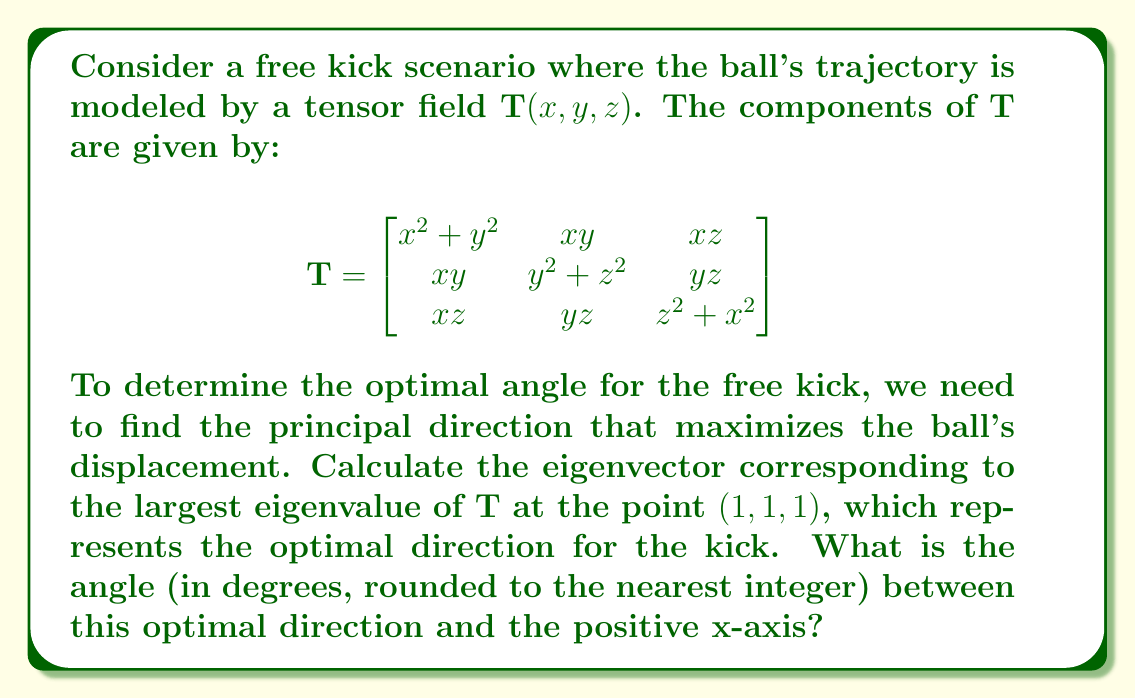Show me your answer to this math problem. To solve this problem, we'll follow these steps:

1) First, we need to evaluate the tensor $\mathbf{T}$ at the point $(1,1,1)$:

   $$\mathbf{T}(1,1,1) = \begin{bmatrix}
   2 & 1 & 1 \\
   1 & 2 & 1 \\
   1 & 1 & 2
   \end{bmatrix}$$

2) Now, we need to find the eigenvalues of this matrix. The characteristic equation is:

   $$\det(\mathbf{T} - \lambda \mathbf{I}) = 0$$
   
   $$\begin{vmatrix}
   2-\lambda & 1 & 1 \\
   1 & 2-\lambda & 1 \\
   1 & 1 & 2-\lambda
   \end{vmatrix} = 0$$

3) Expanding this determinant:

   $$(\lambda-2)^3 + 2 - 3(\lambda-2) = 0$$
   $$\lambda^3 - 6\lambda^2 + 12\lambda - 8 + 2 - 3\lambda + 6 = 0$$
   $$\lambda^3 - 6\lambda^2 + 9\lambda = 0$$
   $$\lambda(\lambda^2 - 6\lambda + 9) = 0$$
   $$\lambda(\lambda - 3)^2 = 0$$

4) The eigenvalues are $\lambda_1 = 3$ (with algebraic multiplicity 2) and $\lambda_2 = 0$.

5) The largest eigenvalue is 3, so we need to find the corresponding eigenvector. We solve:

   $$(\mathbf{T} - 3\mathbf{I})\mathbf{v} = \mathbf{0}$$

   $$\begin{bmatrix}
   -1 & 1 & 1 \\
   1 & -1 & 1 \\
   1 & 1 & -1
   \end{bmatrix}\begin{bmatrix}
   v_1 \\ v_2 \\ v_3
   \end{bmatrix} = \begin{bmatrix}
   0 \\ 0 \\ 0
   \end{bmatrix}$$

6) This system of equations reduces to $v_1 = v_2 = v_3$. Let's choose $v_1 = v_2 = v_3 = 1$.

7) So, the eigenvector is $\mathbf{v} = (1,1,1)$.

8) To find the angle between this vector and the positive x-axis, we use the dot product formula:

   $$\cos \theta = \frac{\mathbf{v} \cdot \mathbf{i}}{\|\mathbf{v}\| \|\mathbf{i}\|}$$

   where $\mathbf{i} = (1,0,0)$ is the unit vector in the x-direction.

9) Calculating:

   $$\cos \theta = \frac{1}{\sqrt{3}}$$

10) Taking the inverse cosine and converting to degrees:

    $$\theta = \arccos(\frac{1}{\sqrt{3}}) \approx 54.7°$$

11) Rounding to the nearest integer:

    $$\theta \approx 55°$$
Answer: 55° 